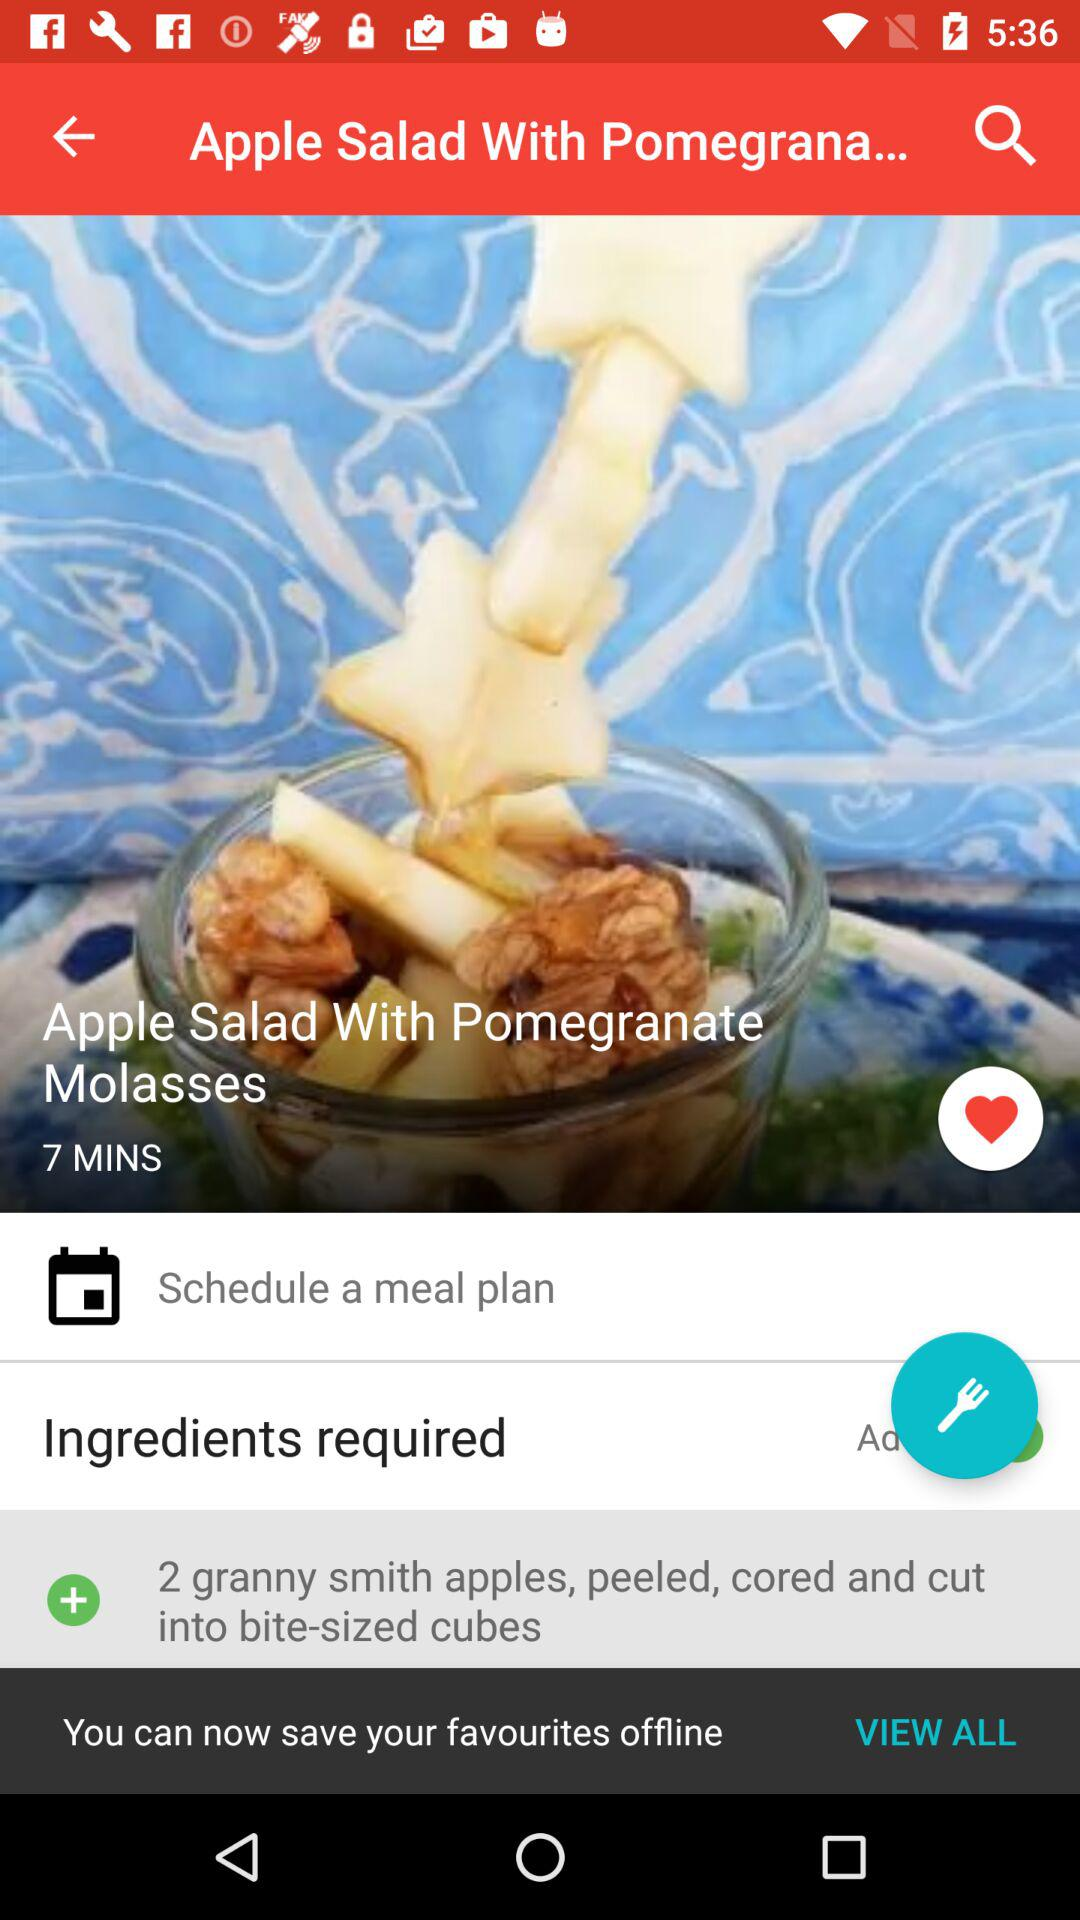In how much time will the dish get cooked? The dish will be cooked in 7 minutes. 